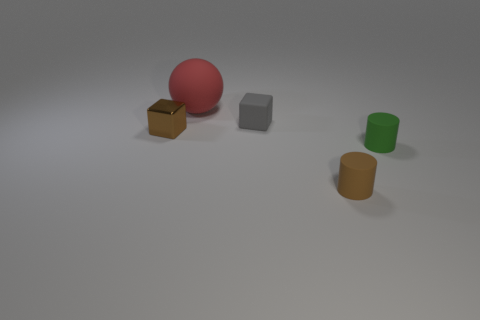Is there any other thing that is made of the same material as the brown cube?
Provide a short and direct response. No. How many other small things have the same shape as the gray rubber object?
Your answer should be very brief. 1. There is a sphere that is the same material as the green thing; what is its size?
Provide a succinct answer. Large. What number of purple rubber spheres are the same size as the brown cylinder?
Your response must be concise. 0. There is a tiny thing that is on the right side of the tiny brown object in front of the small metal object; what is its color?
Make the answer very short. Green. Is there another small thing that has the same color as the small metal object?
Your answer should be compact. Yes. What is the color of the other matte cylinder that is the same size as the green matte cylinder?
Your response must be concise. Brown. Are the brown object to the right of the big red rubber object and the sphere made of the same material?
Keep it short and to the point. Yes. There is a brown thing that is behind the brown thing that is on the right side of the brown metal thing; is there a tiny rubber thing behind it?
Make the answer very short. Yes. There is a brown thing that is on the left side of the large rubber sphere; does it have the same shape as the large red rubber object?
Offer a very short reply. No. 